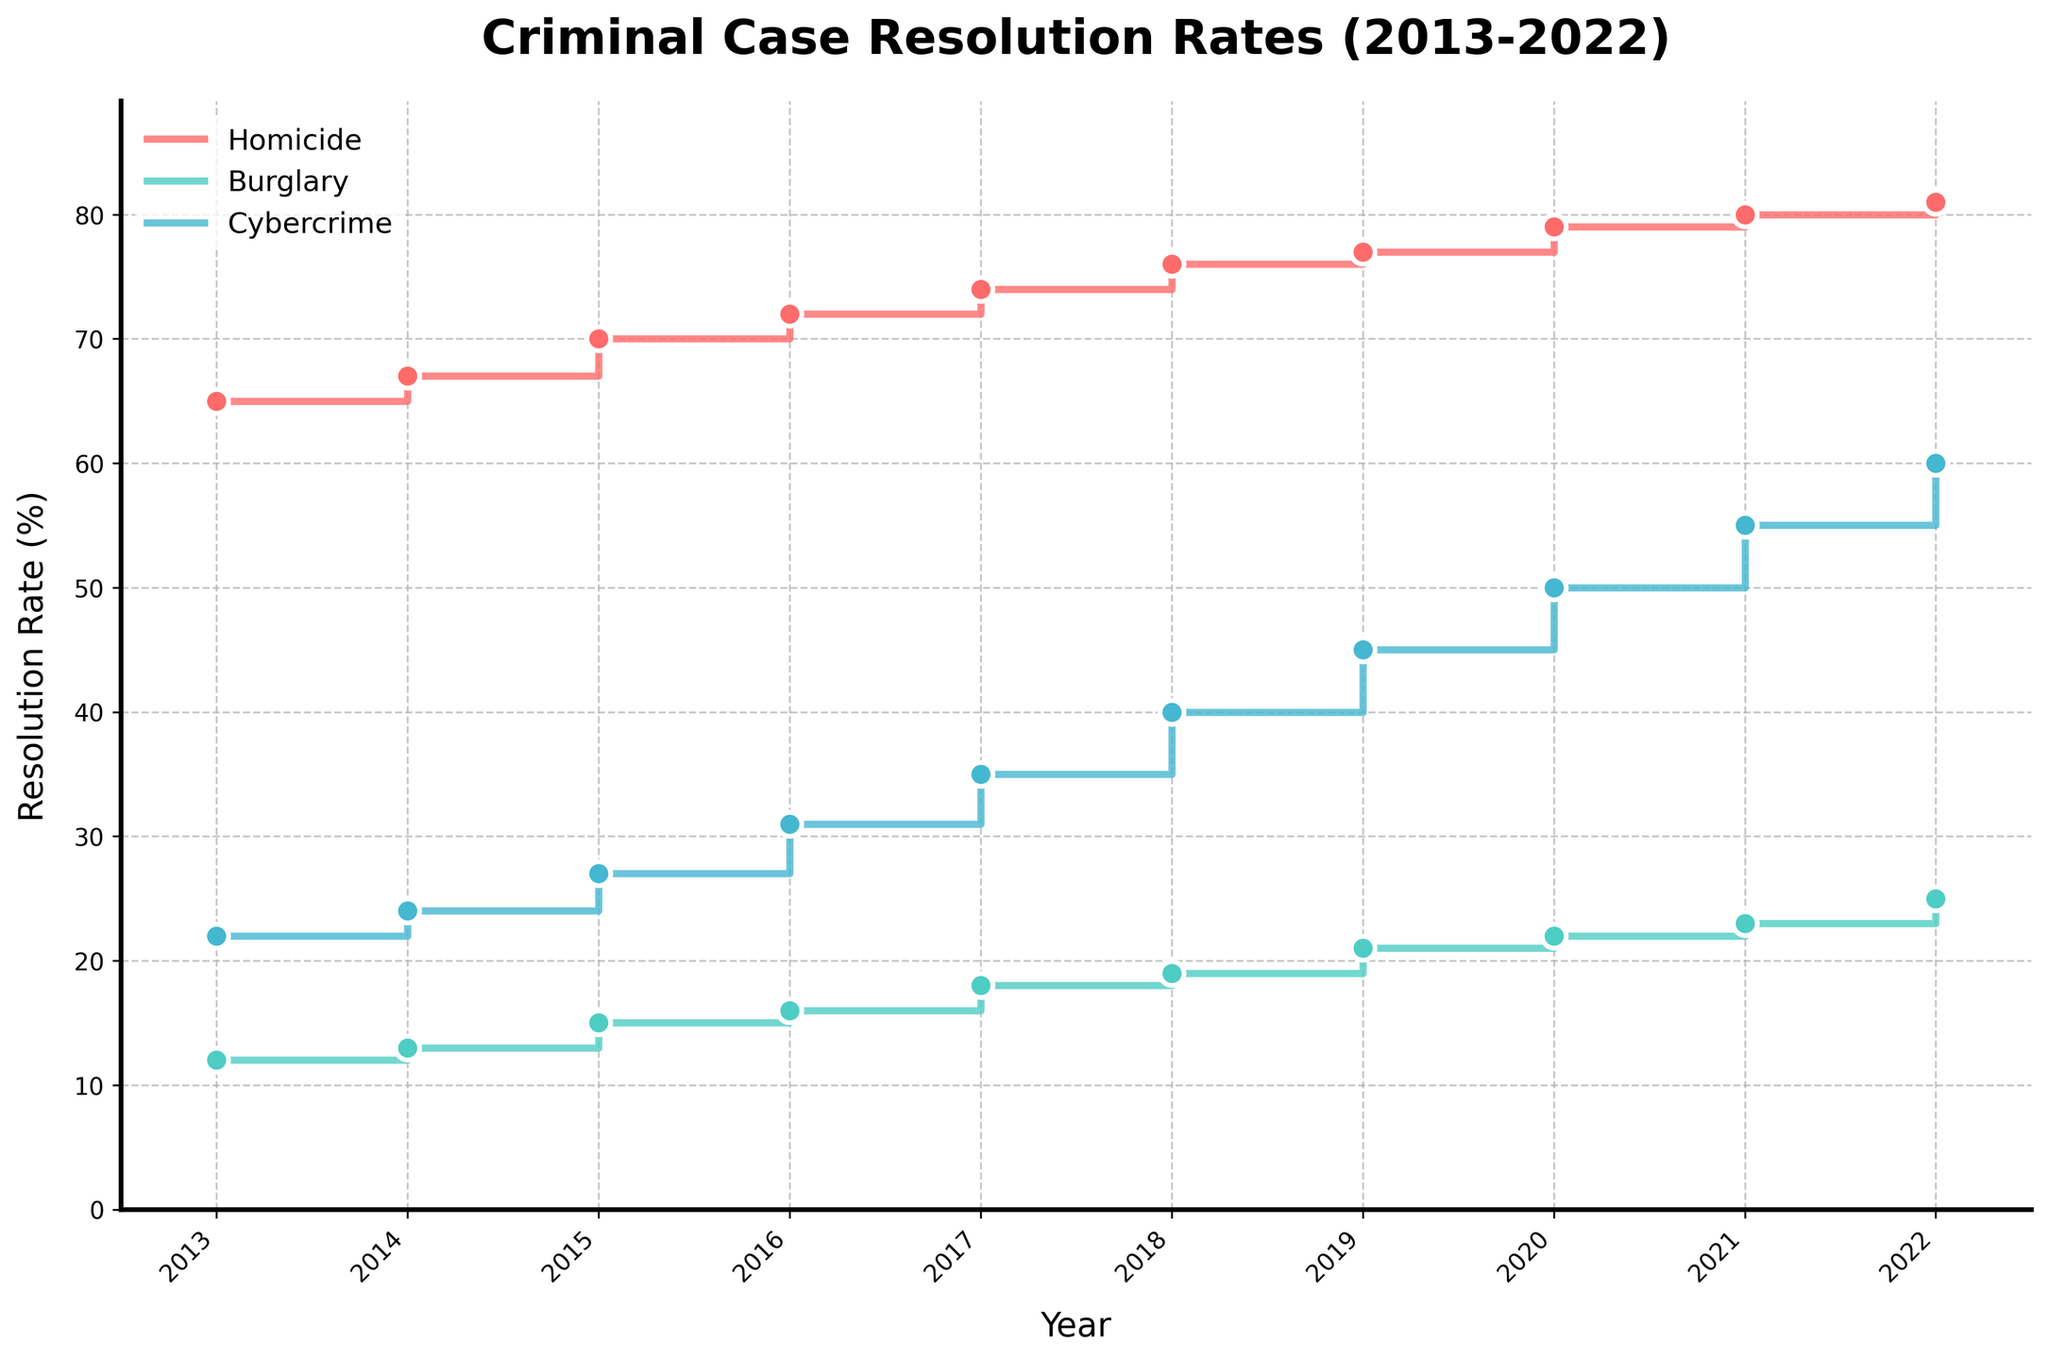What is the highest resolution rate for cybercrime over the years displayed? The highest resolution rate for cybercrime can be identified by locating the highest point on the cybercrime stair plot line. In the year 2022, the resolution rate was 60%, which is the peak value.
Answer: 60% How many years show an increase in burglary resolution rates? By counting each stair-step increase in the burglary resolution rate from one year to the next, we see that it increases every year from 2013 to 2022, giving us a total of 9 increases.
Answer: 9 years Which type of crime had the smallest increase in resolution rate from 2013 to 2022? Calculate the difference in resolution rates from 2013 to 2022 for each crime type: Homicide (81-65=16), Burglary (25-12=13), Cybercrime (60-22=38). Burglary had the smallest increase of 13%.
Answer: Burglary What is the average resolution rate of homicide over the decade? The average can be calculated by summing the annual resolution rates for homicide and dividing by 10 (the number of years). The sum is (65+67+70+72+74+76+77+79+80+81=741) and the average is 741/10.
Answer: 74.1% During which year did cybercrime resolution rates see the most significant increase from the previous year? By examining the stair-step jumps for cybercrime each year, the largest increase can be identified between 2015 and 2016, from 27% to 31%, a jump of 4%.
Answer: 2016 Which crime type saw its resolution rate double over the period? Compare the resolution rate in 2013 and 2022 for each type of crime: Homicide (65 to 81, not doubled), Burglary (12 to 25, not doubled), and Cybercrime (22 to 60). Cybercrime is the only rate that starts below 30 and doubles by 2022.
Answer: Cybercrime In what years did all three crime types have an increase in resolution rate? Check each year to see if the resolution rates for all three crimes increased over the previous year. This happens consistently every year from 2013 to 2022.
Answer: Every year from 2013 to 2022 Between 2019 and 2021, which crime type had the smallest change in resolution rate? Calculate the difference in resolution rates between 2019 and 2021 for each crime type: Homicide (80-77=3), Burglary (23-21=2), Cybercrime (55-45=10). Burglary had the smallest change of 2 percentage points.
Answer: Burglary Which year had the same resolution rate for burglary and cybercrime? Look for a point where the burglary and cybercrime rates match. No year in the dataset shows equal resolution rates for these two types of crime.
Answer: None 